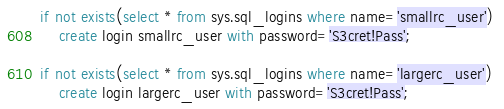Convert code to text. <code><loc_0><loc_0><loc_500><loc_500><_SQL_>if not exists(select * from sys.sql_logins where name='smallrc_user')
	create login smallrc_user with password='S3cret!Pass';

if not exists(select * from sys.sql_logins where name='largerc_user') 
	create login largerc_user with password='S3cret!Pass';
</code> 